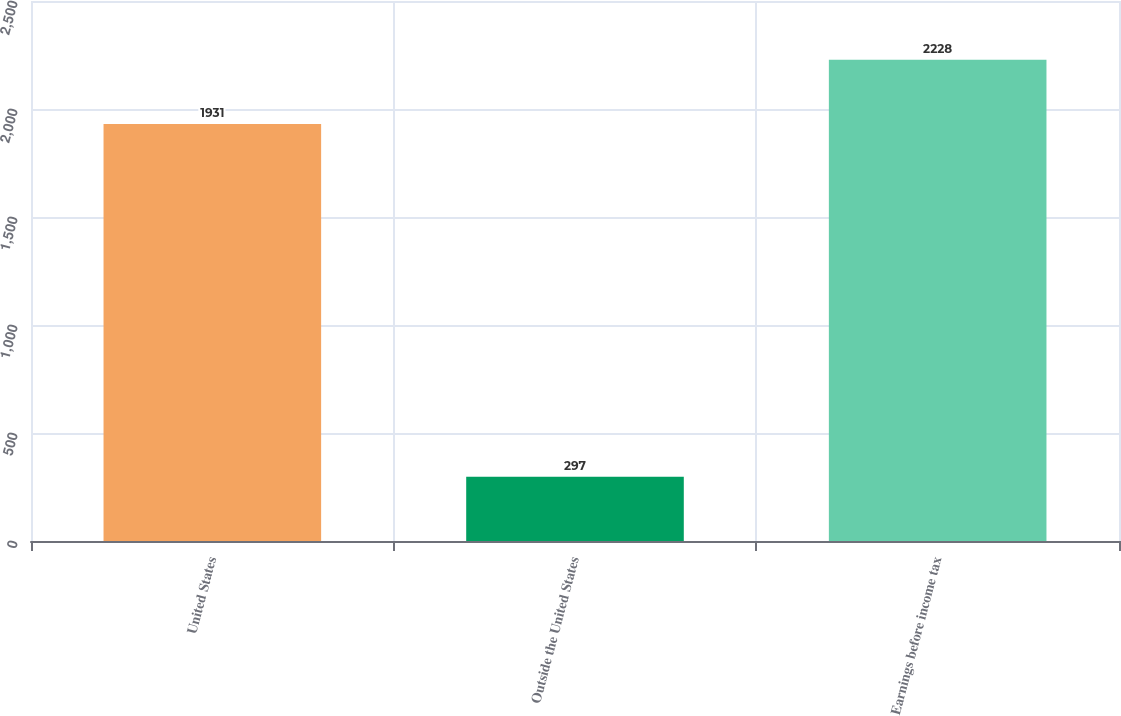Convert chart to OTSL. <chart><loc_0><loc_0><loc_500><loc_500><bar_chart><fcel>United States<fcel>Outside the United States<fcel>Earnings before income tax<nl><fcel>1931<fcel>297<fcel>2228<nl></chart> 